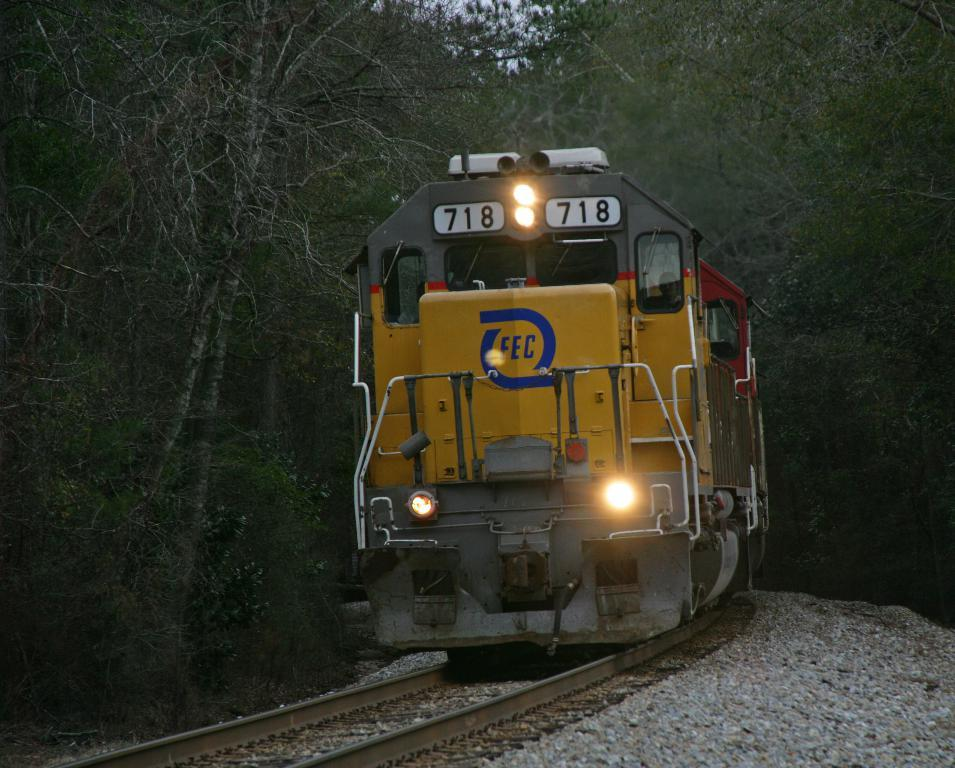What is the main subject of the image? The main subject of the image is a train on a track. What type of terrain can be seen in the image? There are stones visible in the image, which suggests a rocky or stony terrain. What can be seen in the background of the image? There are trees and the sky visible in the background of the image. What type of office furniture can be seen in the image? There is no office furniture present in the image; it features a train on a track, stones, trees, and the sky. What type of patch is visible on the train's side? There is no patch visible on the train's side in the image. 